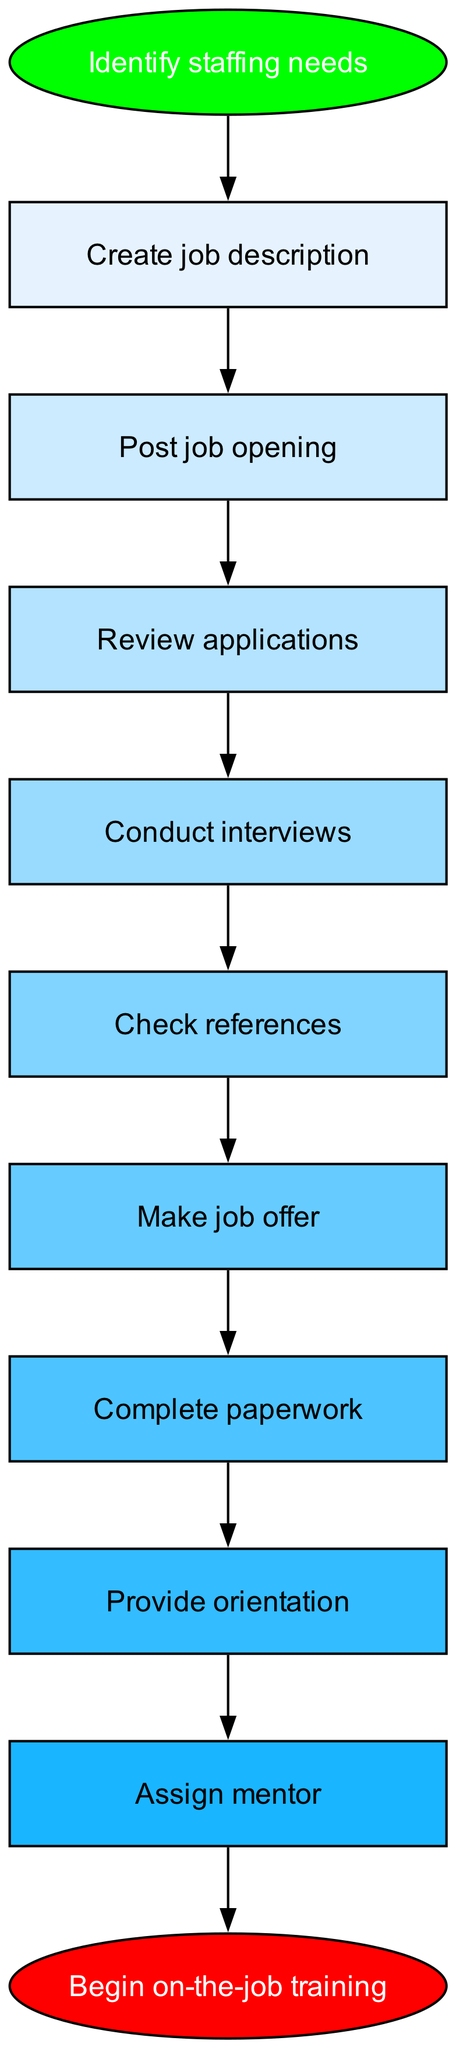What is the first step in the hiring process? The first step in the flowchart is "Identify staffing needs," which is the starting point for the entire hiring procedure.
Answer: Identify staffing needs How many steps are there in total before onboarding begins? By counting the nodes from "Identify staffing needs" to "Begin on-the-job training," we find there are nine steps in total (including the start and end points).
Answer: Nine What comes after "Conduct interviews"? The next step following "Conduct interviews" in the flowchart is "Check references," indicating the order of procedures in the hiring process.
Answer: Check references Which step involves completing necessary documentation? The step referred to is "Complete paperwork," which directly follows the making of a job offer and is essential for the onboarding process.
Answer: Complete paperwork What is the final step after assigning a mentor? The last step in the process, coming after "Assign mentor," is "Begin on-the-job training," which marks the completion of the onboarding phase.
Answer: Begin on-the-job training Which step is represented as an ellipse? The "Identify staffing needs" at the start and "Begin on-the-job training" at the end are both represented as ellipses, indicating their nature as starting and ending points in the flowchart.
Answer: Identify staffing needs, Begin on-the-job training What is the relationship between "Review applications" and "Conduct interviews"? "Review applications" leads directly to "Conduct interviews," which suggests that once applications are reviewed, the next step is to conduct interviews with suitable candidates.
Answer: Conduct interviews How many nodes are there in total? The total number of nodes in the flowchart is eleven, representing important steps in the hiring and onboarding process, including start and end points.
Answer: Eleven 